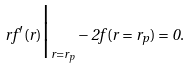<formula> <loc_0><loc_0><loc_500><loc_500>r f ^ { \prime } ( r ) \Big | _ { r = r _ { p } } - 2 f ( r = r _ { p } ) = 0 .</formula> 